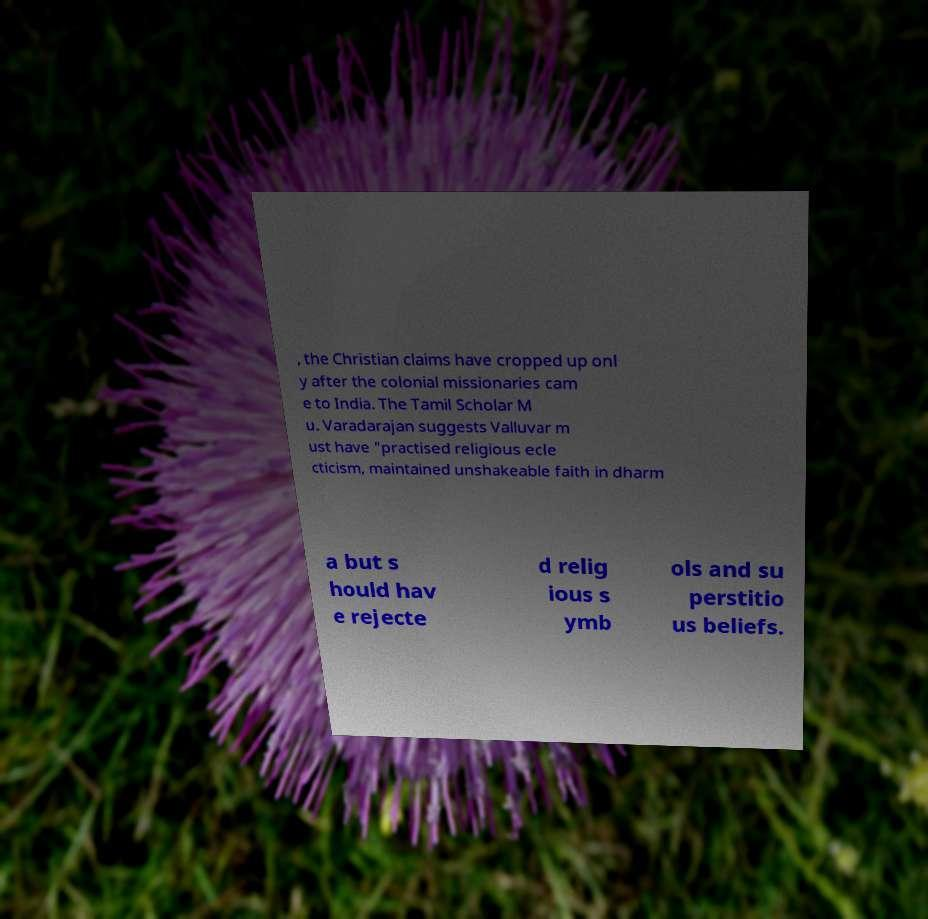Could you assist in decoding the text presented in this image and type it out clearly? , the Christian claims have cropped up onl y after the colonial missionaries cam e to India. The Tamil Scholar M u. Varadarajan suggests Valluvar m ust have "practised religious ecle cticism, maintained unshakeable faith in dharm a but s hould hav e rejecte d relig ious s ymb ols and su perstitio us beliefs. 